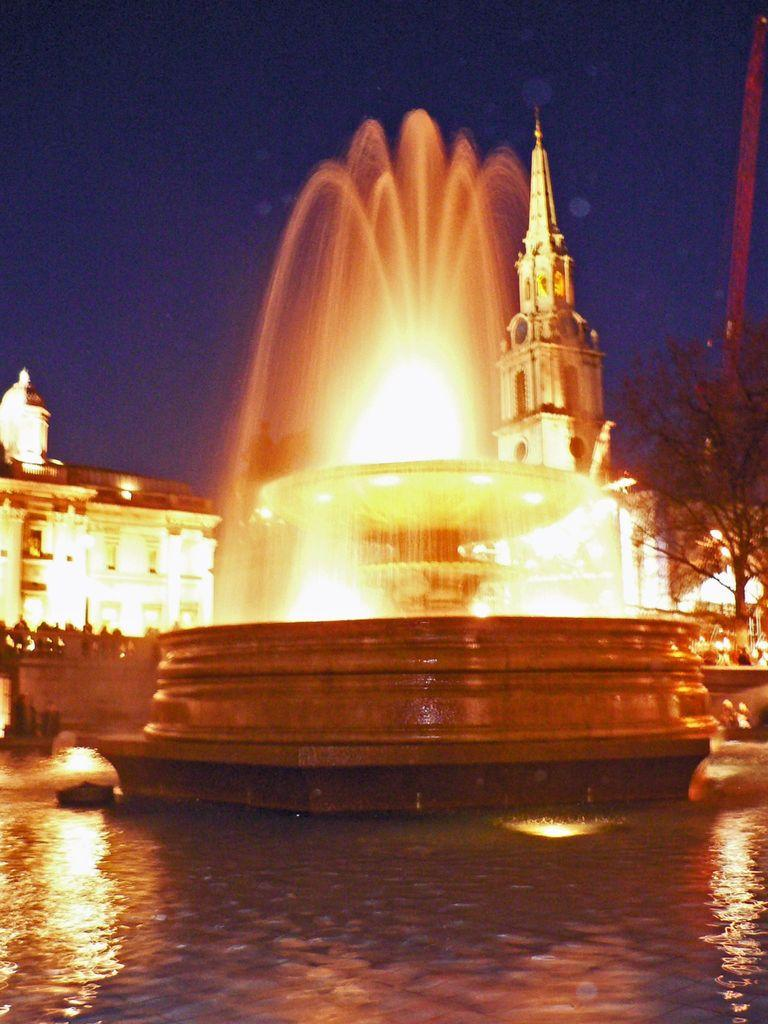What is the main feature in the image? There is a water fountain in the image. What can be seen at the bottom of the image? Water is visible at the bottom of the image. What type of vegetation is on the right side of the image? There is a tree on the right side of the image. What is visible in the background of the image? There are buildings in the background of the image. What is visible at the top of the image? The sky is visible at the top of the image. How does the water fountain shake in the image? The water fountain does not shake in the image; it is stationary. What type of ray is visible in the image? There is no ray visible in the image. 